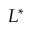Convert formula to latex. <formula><loc_0><loc_0><loc_500><loc_500>L ^ { * }</formula> 